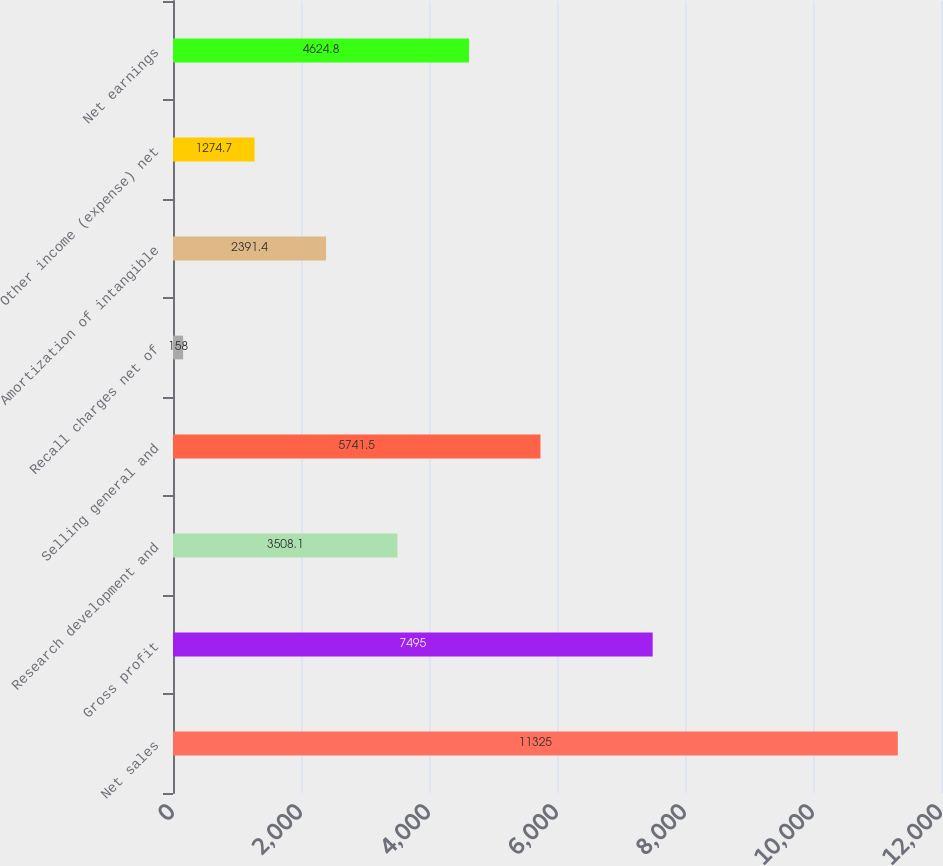Convert chart to OTSL. <chart><loc_0><loc_0><loc_500><loc_500><bar_chart><fcel>Net sales<fcel>Gross profit<fcel>Research development and<fcel>Selling general and<fcel>Recall charges net of<fcel>Amortization of intangible<fcel>Other income (expense) net<fcel>Net earnings<nl><fcel>11325<fcel>7495<fcel>3508.1<fcel>5741.5<fcel>158<fcel>2391.4<fcel>1274.7<fcel>4624.8<nl></chart> 